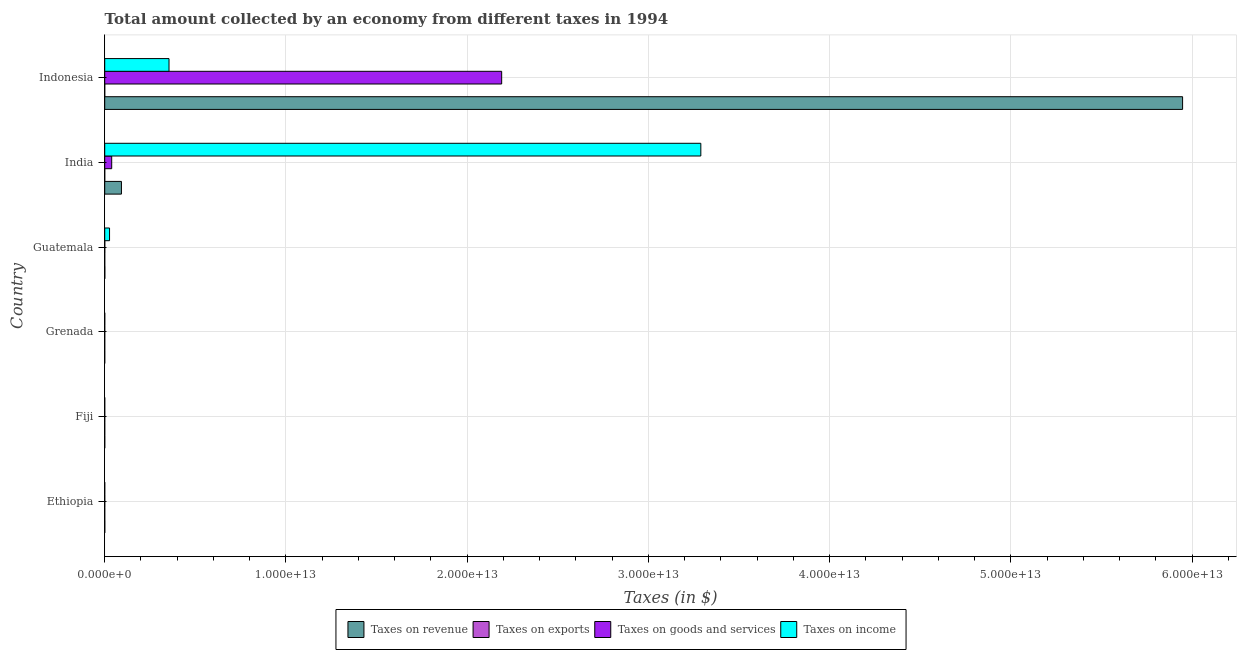How many different coloured bars are there?
Provide a short and direct response. 4. What is the amount collected as tax on goods in Grenada?
Offer a terse response. 8.10e+07. Across all countries, what is the maximum amount collected as tax on income?
Keep it short and to the point. 3.29e+13. Across all countries, what is the minimum amount collected as tax on income?
Your answer should be very brief. 3.48e+07. In which country was the amount collected as tax on exports maximum?
Your answer should be very brief. Fiji. What is the total amount collected as tax on exports in the graph?
Make the answer very short. 6.18e+08. What is the difference between the amount collected as tax on exports in Ethiopia and that in Guatemala?
Keep it short and to the point. -9.68e+07. What is the difference between the amount collected as tax on exports in Grenada and the amount collected as tax on goods in India?
Keep it short and to the point. -3.85e+11. What is the average amount collected as tax on income per country?
Offer a very short reply. 6.12e+12. What is the difference between the amount collected as tax on goods and amount collected as tax on income in Guatemala?
Give a very brief answer. -2.64e+11. In how many countries, is the amount collected as tax on income greater than 54000000000000 $?
Your response must be concise. 0. What is the ratio of the amount collected as tax on income in Guatemala to that in Indonesia?
Provide a short and direct response. 0.07. What is the difference between the highest and the second highest amount collected as tax on income?
Provide a short and direct response. 2.93e+13. What is the difference between the highest and the lowest amount collected as tax on revenue?
Your response must be concise. 5.95e+13. In how many countries, is the amount collected as tax on goods greater than the average amount collected as tax on goods taken over all countries?
Give a very brief answer. 1. Is the sum of the amount collected as tax on revenue in Ethiopia and Guatemala greater than the maximum amount collected as tax on income across all countries?
Your answer should be very brief. No. Is it the case that in every country, the sum of the amount collected as tax on exports and amount collected as tax on goods is greater than the sum of amount collected as tax on income and amount collected as tax on revenue?
Ensure brevity in your answer.  No. What does the 3rd bar from the top in Indonesia represents?
Your response must be concise. Taxes on exports. What does the 1st bar from the bottom in India represents?
Offer a very short reply. Taxes on revenue. How many bars are there?
Your answer should be compact. 24. What is the difference between two consecutive major ticks on the X-axis?
Keep it short and to the point. 1.00e+13. Are the values on the major ticks of X-axis written in scientific E-notation?
Provide a short and direct response. Yes. Does the graph contain any zero values?
Make the answer very short. No. Where does the legend appear in the graph?
Keep it short and to the point. Bottom center. How are the legend labels stacked?
Provide a succinct answer. Horizontal. What is the title of the graph?
Your response must be concise. Total amount collected by an economy from different taxes in 1994. Does "Secondary vocational" appear as one of the legend labels in the graph?
Offer a terse response. No. What is the label or title of the X-axis?
Give a very brief answer. Taxes (in $). What is the Taxes (in $) in Taxes on revenue in Ethiopia?
Provide a short and direct response. 3.08e+09. What is the Taxes (in $) of Taxes on exports in Ethiopia?
Keep it short and to the point. 4.00e+07. What is the Taxes (in $) of Taxes on goods and services in Ethiopia?
Offer a very short reply. 7.72e+08. What is the Taxes (in $) in Taxes on income in Ethiopia?
Offer a very short reply. 1.89e+08. What is the Taxes (in $) of Taxes on revenue in Fiji?
Give a very brief answer. 5.74e+08. What is the Taxes (in $) of Taxes on exports in Fiji?
Offer a terse response. 4.27e+08. What is the Taxes (in $) of Taxes on goods and services in Fiji?
Offer a terse response. 2.19e+08. What is the Taxes (in $) of Taxes on income in Fiji?
Make the answer very short. 3.48e+07. What is the Taxes (in $) of Taxes on revenue in Grenada?
Your answer should be compact. 1.58e+08. What is the Taxes (in $) of Taxes on exports in Grenada?
Make the answer very short. 1.36e+07. What is the Taxes (in $) in Taxes on goods and services in Grenada?
Ensure brevity in your answer.  8.10e+07. What is the Taxes (in $) in Taxes on income in Grenada?
Provide a short and direct response. 8.46e+08. What is the Taxes (in $) of Taxes on revenue in Guatemala?
Make the answer very short. 5.05e+09. What is the Taxes (in $) in Taxes on exports in Guatemala?
Your answer should be very brief. 1.37e+08. What is the Taxes (in $) of Taxes on goods and services in Guatemala?
Provide a succinct answer. 2.78e+09. What is the Taxes (in $) in Taxes on income in Guatemala?
Provide a succinct answer. 2.66e+11. What is the Taxes (in $) in Taxes on revenue in India?
Your response must be concise. 9.23e+11. What is the Taxes (in $) of Taxes on goods and services in India?
Your answer should be compact. 3.85e+11. What is the Taxes (in $) of Taxes on income in India?
Your response must be concise. 3.29e+13. What is the Taxes (in $) in Taxes on revenue in Indonesia?
Give a very brief answer. 5.95e+13. What is the Taxes (in $) of Taxes on exports in Indonesia?
Provide a succinct answer. 9.00e+05. What is the Taxes (in $) in Taxes on goods and services in Indonesia?
Provide a succinct answer. 2.19e+13. What is the Taxes (in $) in Taxes on income in Indonesia?
Your response must be concise. 3.55e+12. Across all countries, what is the maximum Taxes (in $) of Taxes on revenue?
Your response must be concise. 5.95e+13. Across all countries, what is the maximum Taxes (in $) of Taxes on exports?
Offer a very short reply. 4.27e+08. Across all countries, what is the maximum Taxes (in $) of Taxes on goods and services?
Your answer should be very brief. 2.19e+13. Across all countries, what is the maximum Taxes (in $) in Taxes on income?
Make the answer very short. 3.29e+13. Across all countries, what is the minimum Taxes (in $) of Taxes on revenue?
Provide a succinct answer. 1.58e+08. Across all countries, what is the minimum Taxes (in $) in Taxes on exports?
Provide a short and direct response. 10000. Across all countries, what is the minimum Taxes (in $) in Taxes on goods and services?
Make the answer very short. 8.10e+07. Across all countries, what is the minimum Taxes (in $) in Taxes on income?
Offer a very short reply. 3.48e+07. What is the total Taxes (in $) of Taxes on revenue in the graph?
Your answer should be very brief. 6.04e+13. What is the total Taxes (in $) in Taxes on exports in the graph?
Your answer should be compact. 6.18e+08. What is the total Taxes (in $) of Taxes on goods and services in the graph?
Your answer should be compact. 2.23e+13. What is the total Taxes (in $) in Taxes on income in the graph?
Offer a very short reply. 3.67e+13. What is the difference between the Taxes (in $) in Taxes on revenue in Ethiopia and that in Fiji?
Provide a short and direct response. 2.50e+09. What is the difference between the Taxes (in $) in Taxes on exports in Ethiopia and that in Fiji?
Give a very brief answer. -3.87e+08. What is the difference between the Taxes (in $) in Taxes on goods and services in Ethiopia and that in Fiji?
Provide a short and direct response. 5.53e+08. What is the difference between the Taxes (in $) of Taxes on income in Ethiopia and that in Fiji?
Provide a short and direct response. 1.54e+08. What is the difference between the Taxes (in $) of Taxes on revenue in Ethiopia and that in Grenada?
Offer a very short reply. 2.92e+09. What is the difference between the Taxes (in $) in Taxes on exports in Ethiopia and that in Grenada?
Keep it short and to the point. 2.64e+07. What is the difference between the Taxes (in $) in Taxes on goods and services in Ethiopia and that in Grenada?
Your answer should be very brief. 6.91e+08. What is the difference between the Taxes (in $) of Taxes on income in Ethiopia and that in Grenada?
Offer a very short reply. -6.57e+08. What is the difference between the Taxes (in $) in Taxes on revenue in Ethiopia and that in Guatemala?
Ensure brevity in your answer.  -1.98e+09. What is the difference between the Taxes (in $) of Taxes on exports in Ethiopia and that in Guatemala?
Your response must be concise. -9.68e+07. What is the difference between the Taxes (in $) in Taxes on goods and services in Ethiopia and that in Guatemala?
Give a very brief answer. -2.01e+09. What is the difference between the Taxes (in $) in Taxes on income in Ethiopia and that in Guatemala?
Make the answer very short. -2.66e+11. What is the difference between the Taxes (in $) of Taxes on revenue in Ethiopia and that in India?
Give a very brief answer. -9.20e+11. What is the difference between the Taxes (in $) in Taxes on exports in Ethiopia and that in India?
Keep it short and to the point. 4.00e+07. What is the difference between the Taxes (in $) of Taxes on goods and services in Ethiopia and that in India?
Give a very brief answer. -3.84e+11. What is the difference between the Taxes (in $) in Taxes on income in Ethiopia and that in India?
Offer a terse response. -3.29e+13. What is the difference between the Taxes (in $) in Taxes on revenue in Ethiopia and that in Indonesia?
Give a very brief answer. -5.95e+13. What is the difference between the Taxes (in $) in Taxes on exports in Ethiopia and that in Indonesia?
Ensure brevity in your answer.  3.91e+07. What is the difference between the Taxes (in $) of Taxes on goods and services in Ethiopia and that in Indonesia?
Provide a succinct answer. -2.19e+13. What is the difference between the Taxes (in $) in Taxes on income in Ethiopia and that in Indonesia?
Offer a very short reply. -3.55e+12. What is the difference between the Taxes (in $) of Taxes on revenue in Fiji and that in Grenada?
Keep it short and to the point. 4.17e+08. What is the difference between the Taxes (in $) of Taxes on exports in Fiji and that in Grenada?
Your answer should be compact. 4.13e+08. What is the difference between the Taxes (in $) of Taxes on goods and services in Fiji and that in Grenada?
Offer a very short reply. 1.38e+08. What is the difference between the Taxes (in $) of Taxes on income in Fiji and that in Grenada?
Your answer should be very brief. -8.11e+08. What is the difference between the Taxes (in $) in Taxes on revenue in Fiji and that in Guatemala?
Offer a terse response. -4.48e+09. What is the difference between the Taxes (in $) in Taxes on exports in Fiji and that in Guatemala?
Your answer should be very brief. 2.90e+08. What is the difference between the Taxes (in $) in Taxes on goods and services in Fiji and that in Guatemala?
Ensure brevity in your answer.  -2.56e+09. What is the difference between the Taxes (in $) in Taxes on income in Fiji and that in Guatemala?
Provide a short and direct response. -2.66e+11. What is the difference between the Taxes (in $) in Taxes on revenue in Fiji and that in India?
Make the answer very short. -9.22e+11. What is the difference between the Taxes (in $) of Taxes on exports in Fiji and that in India?
Provide a succinct answer. 4.27e+08. What is the difference between the Taxes (in $) in Taxes on goods and services in Fiji and that in India?
Give a very brief answer. -3.85e+11. What is the difference between the Taxes (in $) of Taxes on income in Fiji and that in India?
Provide a short and direct response. -3.29e+13. What is the difference between the Taxes (in $) of Taxes on revenue in Fiji and that in Indonesia?
Make the answer very short. -5.95e+13. What is the difference between the Taxes (in $) of Taxes on exports in Fiji and that in Indonesia?
Offer a terse response. 4.26e+08. What is the difference between the Taxes (in $) of Taxes on goods and services in Fiji and that in Indonesia?
Offer a terse response. -2.19e+13. What is the difference between the Taxes (in $) of Taxes on income in Fiji and that in Indonesia?
Your answer should be compact. -3.55e+12. What is the difference between the Taxes (in $) in Taxes on revenue in Grenada and that in Guatemala?
Make the answer very short. -4.89e+09. What is the difference between the Taxes (in $) of Taxes on exports in Grenada and that in Guatemala?
Provide a short and direct response. -1.23e+08. What is the difference between the Taxes (in $) of Taxes on goods and services in Grenada and that in Guatemala?
Provide a short and direct response. -2.70e+09. What is the difference between the Taxes (in $) in Taxes on income in Grenada and that in Guatemala?
Give a very brief answer. -2.66e+11. What is the difference between the Taxes (in $) in Taxes on revenue in Grenada and that in India?
Offer a very short reply. -9.23e+11. What is the difference between the Taxes (in $) of Taxes on exports in Grenada and that in India?
Make the answer very short. 1.36e+07. What is the difference between the Taxes (in $) of Taxes on goods and services in Grenada and that in India?
Ensure brevity in your answer.  -3.85e+11. What is the difference between the Taxes (in $) in Taxes on income in Grenada and that in India?
Your answer should be very brief. -3.29e+13. What is the difference between the Taxes (in $) in Taxes on revenue in Grenada and that in Indonesia?
Provide a short and direct response. -5.95e+13. What is the difference between the Taxes (in $) in Taxes on exports in Grenada and that in Indonesia?
Offer a terse response. 1.27e+07. What is the difference between the Taxes (in $) of Taxes on goods and services in Grenada and that in Indonesia?
Offer a terse response. -2.19e+13. What is the difference between the Taxes (in $) in Taxes on income in Grenada and that in Indonesia?
Keep it short and to the point. -3.55e+12. What is the difference between the Taxes (in $) in Taxes on revenue in Guatemala and that in India?
Provide a succinct answer. -9.18e+11. What is the difference between the Taxes (in $) in Taxes on exports in Guatemala and that in India?
Your answer should be very brief. 1.37e+08. What is the difference between the Taxes (in $) in Taxes on goods and services in Guatemala and that in India?
Offer a very short reply. -3.82e+11. What is the difference between the Taxes (in $) in Taxes on income in Guatemala and that in India?
Your answer should be compact. -3.26e+13. What is the difference between the Taxes (in $) in Taxes on revenue in Guatemala and that in Indonesia?
Offer a terse response. -5.95e+13. What is the difference between the Taxes (in $) of Taxes on exports in Guatemala and that in Indonesia?
Keep it short and to the point. 1.36e+08. What is the difference between the Taxes (in $) in Taxes on goods and services in Guatemala and that in Indonesia?
Your response must be concise. -2.19e+13. What is the difference between the Taxes (in $) in Taxes on income in Guatemala and that in Indonesia?
Keep it short and to the point. -3.28e+12. What is the difference between the Taxes (in $) in Taxes on revenue in India and that in Indonesia?
Give a very brief answer. -5.86e+13. What is the difference between the Taxes (in $) of Taxes on exports in India and that in Indonesia?
Provide a short and direct response. -8.90e+05. What is the difference between the Taxes (in $) in Taxes on goods and services in India and that in Indonesia?
Offer a terse response. -2.15e+13. What is the difference between the Taxes (in $) of Taxes on income in India and that in Indonesia?
Ensure brevity in your answer.  2.93e+13. What is the difference between the Taxes (in $) in Taxes on revenue in Ethiopia and the Taxes (in $) in Taxes on exports in Fiji?
Ensure brevity in your answer.  2.65e+09. What is the difference between the Taxes (in $) of Taxes on revenue in Ethiopia and the Taxes (in $) of Taxes on goods and services in Fiji?
Offer a terse response. 2.86e+09. What is the difference between the Taxes (in $) of Taxes on revenue in Ethiopia and the Taxes (in $) of Taxes on income in Fiji?
Ensure brevity in your answer.  3.04e+09. What is the difference between the Taxes (in $) of Taxes on exports in Ethiopia and the Taxes (in $) of Taxes on goods and services in Fiji?
Make the answer very short. -1.79e+08. What is the difference between the Taxes (in $) of Taxes on exports in Ethiopia and the Taxes (in $) of Taxes on income in Fiji?
Keep it short and to the point. 5.20e+06. What is the difference between the Taxes (in $) in Taxes on goods and services in Ethiopia and the Taxes (in $) in Taxes on income in Fiji?
Make the answer very short. 7.37e+08. What is the difference between the Taxes (in $) in Taxes on revenue in Ethiopia and the Taxes (in $) in Taxes on exports in Grenada?
Provide a short and direct response. 3.06e+09. What is the difference between the Taxes (in $) in Taxes on revenue in Ethiopia and the Taxes (in $) in Taxes on goods and services in Grenada?
Provide a short and direct response. 3.00e+09. What is the difference between the Taxes (in $) of Taxes on revenue in Ethiopia and the Taxes (in $) of Taxes on income in Grenada?
Provide a succinct answer. 2.23e+09. What is the difference between the Taxes (in $) of Taxes on exports in Ethiopia and the Taxes (in $) of Taxes on goods and services in Grenada?
Your answer should be very brief. -4.10e+07. What is the difference between the Taxes (in $) of Taxes on exports in Ethiopia and the Taxes (in $) of Taxes on income in Grenada?
Offer a terse response. -8.06e+08. What is the difference between the Taxes (in $) of Taxes on goods and services in Ethiopia and the Taxes (in $) of Taxes on income in Grenada?
Keep it short and to the point. -7.44e+07. What is the difference between the Taxes (in $) in Taxes on revenue in Ethiopia and the Taxes (in $) in Taxes on exports in Guatemala?
Provide a short and direct response. 2.94e+09. What is the difference between the Taxes (in $) of Taxes on revenue in Ethiopia and the Taxes (in $) of Taxes on goods and services in Guatemala?
Give a very brief answer. 2.97e+08. What is the difference between the Taxes (in $) in Taxes on revenue in Ethiopia and the Taxes (in $) in Taxes on income in Guatemala?
Keep it short and to the point. -2.63e+11. What is the difference between the Taxes (in $) in Taxes on exports in Ethiopia and the Taxes (in $) in Taxes on goods and services in Guatemala?
Offer a very short reply. -2.74e+09. What is the difference between the Taxes (in $) of Taxes on exports in Ethiopia and the Taxes (in $) of Taxes on income in Guatemala?
Give a very brief answer. -2.66e+11. What is the difference between the Taxes (in $) in Taxes on goods and services in Ethiopia and the Taxes (in $) in Taxes on income in Guatemala?
Give a very brief answer. -2.66e+11. What is the difference between the Taxes (in $) of Taxes on revenue in Ethiopia and the Taxes (in $) of Taxes on exports in India?
Your answer should be compact. 3.08e+09. What is the difference between the Taxes (in $) in Taxes on revenue in Ethiopia and the Taxes (in $) in Taxes on goods and services in India?
Your answer should be very brief. -3.82e+11. What is the difference between the Taxes (in $) of Taxes on revenue in Ethiopia and the Taxes (in $) of Taxes on income in India?
Ensure brevity in your answer.  -3.29e+13. What is the difference between the Taxes (in $) of Taxes on exports in Ethiopia and the Taxes (in $) of Taxes on goods and services in India?
Offer a very short reply. -3.85e+11. What is the difference between the Taxes (in $) in Taxes on exports in Ethiopia and the Taxes (in $) in Taxes on income in India?
Keep it short and to the point. -3.29e+13. What is the difference between the Taxes (in $) in Taxes on goods and services in Ethiopia and the Taxes (in $) in Taxes on income in India?
Your answer should be very brief. -3.29e+13. What is the difference between the Taxes (in $) of Taxes on revenue in Ethiopia and the Taxes (in $) of Taxes on exports in Indonesia?
Your response must be concise. 3.08e+09. What is the difference between the Taxes (in $) of Taxes on revenue in Ethiopia and the Taxes (in $) of Taxes on goods and services in Indonesia?
Your response must be concise. -2.19e+13. What is the difference between the Taxes (in $) in Taxes on revenue in Ethiopia and the Taxes (in $) in Taxes on income in Indonesia?
Your response must be concise. -3.54e+12. What is the difference between the Taxes (in $) of Taxes on exports in Ethiopia and the Taxes (in $) of Taxes on goods and services in Indonesia?
Offer a very short reply. -2.19e+13. What is the difference between the Taxes (in $) in Taxes on exports in Ethiopia and the Taxes (in $) in Taxes on income in Indonesia?
Give a very brief answer. -3.55e+12. What is the difference between the Taxes (in $) in Taxes on goods and services in Ethiopia and the Taxes (in $) in Taxes on income in Indonesia?
Make the answer very short. -3.55e+12. What is the difference between the Taxes (in $) of Taxes on revenue in Fiji and the Taxes (in $) of Taxes on exports in Grenada?
Provide a short and direct response. 5.61e+08. What is the difference between the Taxes (in $) of Taxes on revenue in Fiji and the Taxes (in $) of Taxes on goods and services in Grenada?
Provide a succinct answer. 4.93e+08. What is the difference between the Taxes (in $) of Taxes on revenue in Fiji and the Taxes (in $) of Taxes on income in Grenada?
Keep it short and to the point. -2.72e+08. What is the difference between the Taxes (in $) of Taxes on exports in Fiji and the Taxes (in $) of Taxes on goods and services in Grenada?
Ensure brevity in your answer.  3.46e+08. What is the difference between the Taxes (in $) of Taxes on exports in Fiji and the Taxes (in $) of Taxes on income in Grenada?
Give a very brief answer. -4.19e+08. What is the difference between the Taxes (in $) in Taxes on goods and services in Fiji and the Taxes (in $) in Taxes on income in Grenada?
Ensure brevity in your answer.  -6.27e+08. What is the difference between the Taxes (in $) in Taxes on revenue in Fiji and the Taxes (in $) in Taxes on exports in Guatemala?
Offer a very short reply. 4.38e+08. What is the difference between the Taxes (in $) of Taxes on revenue in Fiji and the Taxes (in $) of Taxes on goods and services in Guatemala?
Offer a terse response. -2.20e+09. What is the difference between the Taxes (in $) of Taxes on revenue in Fiji and the Taxes (in $) of Taxes on income in Guatemala?
Make the answer very short. -2.66e+11. What is the difference between the Taxes (in $) in Taxes on exports in Fiji and the Taxes (in $) in Taxes on goods and services in Guatemala?
Offer a very short reply. -2.35e+09. What is the difference between the Taxes (in $) in Taxes on exports in Fiji and the Taxes (in $) in Taxes on income in Guatemala?
Provide a short and direct response. -2.66e+11. What is the difference between the Taxes (in $) of Taxes on goods and services in Fiji and the Taxes (in $) of Taxes on income in Guatemala?
Provide a succinct answer. -2.66e+11. What is the difference between the Taxes (in $) of Taxes on revenue in Fiji and the Taxes (in $) of Taxes on exports in India?
Offer a very short reply. 5.74e+08. What is the difference between the Taxes (in $) of Taxes on revenue in Fiji and the Taxes (in $) of Taxes on goods and services in India?
Provide a short and direct response. -3.85e+11. What is the difference between the Taxes (in $) of Taxes on revenue in Fiji and the Taxes (in $) of Taxes on income in India?
Provide a succinct answer. -3.29e+13. What is the difference between the Taxes (in $) of Taxes on exports in Fiji and the Taxes (in $) of Taxes on goods and services in India?
Provide a short and direct response. -3.85e+11. What is the difference between the Taxes (in $) in Taxes on exports in Fiji and the Taxes (in $) in Taxes on income in India?
Provide a short and direct response. -3.29e+13. What is the difference between the Taxes (in $) in Taxes on goods and services in Fiji and the Taxes (in $) in Taxes on income in India?
Your response must be concise. -3.29e+13. What is the difference between the Taxes (in $) in Taxes on revenue in Fiji and the Taxes (in $) in Taxes on exports in Indonesia?
Provide a succinct answer. 5.74e+08. What is the difference between the Taxes (in $) in Taxes on revenue in Fiji and the Taxes (in $) in Taxes on goods and services in Indonesia?
Make the answer very short. -2.19e+13. What is the difference between the Taxes (in $) in Taxes on revenue in Fiji and the Taxes (in $) in Taxes on income in Indonesia?
Your answer should be compact. -3.55e+12. What is the difference between the Taxes (in $) in Taxes on exports in Fiji and the Taxes (in $) in Taxes on goods and services in Indonesia?
Give a very brief answer. -2.19e+13. What is the difference between the Taxes (in $) of Taxes on exports in Fiji and the Taxes (in $) of Taxes on income in Indonesia?
Keep it short and to the point. -3.55e+12. What is the difference between the Taxes (in $) in Taxes on goods and services in Fiji and the Taxes (in $) in Taxes on income in Indonesia?
Give a very brief answer. -3.55e+12. What is the difference between the Taxes (in $) of Taxes on revenue in Grenada and the Taxes (in $) of Taxes on exports in Guatemala?
Ensure brevity in your answer.  2.11e+07. What is the difference between the Taxes (in $) of Taxes on revenue in Grenada and the Taxes (in $) of Taxes on goods and services in Guatemala?
Provide a succinct answer. -2.62e+09. What is the difference between the Taxes (in $) in Taxes on revenue in Grenada and the Taxes (in $) in Taxes on income in Guatemala?
Keep it short and to the point. -2.66e+11. What is the difference between the Taxes (in $) of Taxes on exports in Grenada and the Taxes (in $) of Taxes on goods and services in Guatemala?
Provide a succinct answer. -2.77e+09. What is the difference between the Taxes (in $) of Taxes on exports in Grenada and the Taxes (in $) of Taxes on income in Guatemala?
Give a very brief answer. -2.66e+11. What is the difference between the Taxes (in $) of Taxes on goods and services in Grenada and the Taxes (in $) of Taxes on income in Guatemala?
Offer a very short reply. -2.66e+11. What is the difference between the Taxes (in $) in Taxes on revenue in Grenada and the Taxes (in $) in Taxes on exports in India?
Provide a short and direct response. 1.58e+08. What is the difference between the Taxes (in $) of Taxes on revenue in Grenada and the Taxes (in $) of Taxes on goods and services in India?
Your answer should be very brief. -3.85e+11. What is the difference between the Taxes (in $) of Taxes on revenue in Grenada and the Taxes (in $) of Taxes on income in India?
Keep it short and to the point. -3.29e+13. What is the difference between the Taxes (in $) in Taxes on exports in Grenada and the Taxes (in $) in Taxes on goods and services in India?
Provide a succinct answer. -3.85e+11. What is the difference between the Taxes (in $) in Taxes on exports in Grenada and the Taxes (in $) in Taxes on income in India?
Your answer should be compact. -3.29e+13. What is the difference between the Taxes (in $) of Taxes on goods and services in Grenada and the Taxes (in $) of Taxes on income in India?
Keep it short and to the point. -3.29e+13. What is the difference between the Taxes (in $) in Taxes on revenue in Grenada and the Taxes (in $) in Taxes on exports in Indonesia?
Ensure brevity in your answer.  1.57e+08. What is the difference between the Taxes (in $) of Taxes on revenue in Grenada and the Taxes (in $) of Taxes on goods and services in Indonesia?
Make the answer very short. -2.19e+13. What is the difference between the Taxes (in $) of Taxes on revenue in Grenada and the Taxes (in $) of Taxes on income in Indonesia?
Provide a succinct answer. -3.55e+12. What is the difference between the Taxes (in $) of Taxes on exports in Grenada and the Taxes (in $) of Taxes on goods and services in Indonesia?
Provide a succinct answer. -2.19e+13. What is the difference between the Taxes (in $) of Taxes on exports in Grenada and the Taxes (in $) of Taxes on income in Indonesia?
Offer a terse response. -3.55e+12. What is the difference between the Taxes (in $) in Taxes on goods and services in Grenada and the Taxes (in $) in Taxes on income in Indonesia?
Keep it short and to the point. -3.55e+12. What is the difference between the Taxes (in $) in Taxes on revenue in Guatemala and the Taxes (in $) in Taxes on exports in India?
Give a very brief answer. 5.05e+09. What is the difference between the Taxes (in $) of Taxes on revenue in Guatemala and the Taxes (in $) of Taxes on goods and services in India?
Your answer should be very brief. -3.80e+11. What is the difference between the Taxes (in $) in Taxes on revenue in Guatemala and the Taxes (in $) in Taxes on income in India?
Provide a short and direct response. -3.29e+13. What is the difference between the Taxes (in $) in Taxes on exports in Guatemala and the Taxes (in $) in Taxes on goods and services in India?
Make the answer very short. -3.85e+11. What is the difference between the Taxes (in $) of Taxes on exports in Guatemala and the Taxes (in $) of Taxes on income in India?
Offer a terse response. -3.29e+13. What is the difference between the Taxes (in $) of Taxes on goods and services in Guatemala and the Taxes (in $) of Taxes on income in India?
Give a very brief answer. -3.29e+13. What is the difference between the Taxes (in $) in Taxes on revenue in Guatemala and the Taxes (in $) in Taxes on exports in Indonesia?
Keep it short and to the point. 5.05e+09. What is the difference between the Taxes (in $) of Taxes on revenue in Guatemala and the Taxes (in $) of Taxes on goods and services in Indonesia?
Give a very brief answer. -2.19e+13. What is the difference between the Taxes (in $) in Taxes on revenue in Guatemala and the Taxes (in $) in Taxes on income in Indonesia?
Your answer should be very brief. -3.54e+12. What is the difference between the Taxes (in $) in Taxes on exports in Guatemala and the Taxes (in $) in Taxes on goods and services in Indonesia?
Make the answer very short. -2.19e+13. What is the difference between the Taxes (in $) in Taxes on exports in Guatemala and the Taxes (in $) in Taxes on income in Indonesia?
Your answer should be compact. -3.55e+12. What is the difference between the Taxes (in $) in Taxes on goods and services in Guatemala and the Taxes (in $) in Taxes on income in Indonesia?
Your response must be concise. -3.55e+12. What is the difference between the Taxes (in $) in Taxes on revenue in India and the Taxes (in $) in Taxes on exports in Indonesia?
Your response must be concise. 9.23e+11. What is the difference between the Taxes (in $) in Taxes on revenue in India and the Taxes (in $) in Taxes on goods and services in Indonesia?
Make the answer very short. -2.10e+13. What is the difference between the Taxes (in $) of Taxes on revenue in India and the Taxes (in $) of Taxes on income in Indonesia?
Make the answer very short. -2.63e+12. What is the difference between the Taxes (in $) in Taxes on exports in India and the Taxes (in $) in Taxes on goods and services in Indonesia?
Your answer should be very brief. -2.19e+13. What is the difference between the Taxes (in $) in Taxes on exports in India and the Taxes (in $) in Taxes on income in Indonesia?
Ensure brevity in your answer.  -3.55e+12. What is the difference between the Taxes (in $) of Taxes on goods and services in India and the Taxes (in $) of Taxes on income in Indonesia?
Your answer should be very brief. -3.16e+12. What is the average Taxes (in $) of Taxes on revenue per country?
Keep it short and to the point. 1.01e+13. What is the average Taxes (in $) in Taxes on exports per country?
Offer a terse response. 1.03e+08. What is the average Taxes (in $) in Taxes on goods and services per country?
Provide a succinct answer. 3.72e+12. What is the average Taxes (in $) of Taxes on income per country?
Provide a short and direct response. 6.12e+12. What is the difference between the Taxes (in $) of Taxes on revenue and Taxes (in $) of Taxes on exports in Ethiopia?
Give a very brief answer. 3.04e+09. What is the difference between the Taxes (in $) of Taxes on revenue and Taxes (in $) of Taxes on goods and services in Ethiopia?
Make the answer very short. 2.30e+09. What is the difference between the Taxes (in $) in Taxes on revenue and Taxes (in $) in Taxes on income in Ethiopia?
Offer a very short reply. 2.89e+09. What is the difference between the Taxes (in $) of Taxes on exports and Taxes (in $) of Taxes on goods and services in Ethiopia?
Provide a succinct answer. -7.32e+08. What is the difference between the Taxes (in $) of Taxes on exports and Taxes (in $) of Taxes on income in Ethiopia?
Offer a terse response. -1.49e+08. What is the difference between the Taxes (in $) of Taxes on goods and services and Taxes (in $) of Taxes on income in Ethiopia?
Offer a terse response. 5.83e+08. What is the difference between the Taxes (in $) in Taxes on revenue and Taxes (in $) in Taxes on exports in Fiji?
Give a very brief answer. 1.47e+08. What is the difference between the Taxes (in $) in Taxes on revenue and Taxes (in $) in Taxes on goods and services in Fiji?
Offer a very short reply. 3.55e+08. What is the difference between the Taxes (in $) of Taxes on revenue and Taxes (in $) of Taxes on income in Fiji?
Provide a succinct answer. 5.40e+08. What is the difference between the Taxes (in $) of Taxes on exports and Taxes (in $) of Taxes on goods and services in Fiji?
Provide a short and direct response. 2.08e+08. What is the difference between the Taxes (in $) in Taxes on exports and Taxes (in $) in Taxes on income in Fiji?
Your answer should be very brief. 3.92e+08. What is the difference between the Taxes (in $) of Taxes on goods and services and Taxes (in $) of Taxes on income in Fiji?
Your response must be concise. 1.84e+08. What is the difference between the Taxes (in $) in Taxes on revenue and Taxes (in $) in Taxes on exports in Grenada?
Your response must be concise. 1.44e+08. What is the difference between the Taxes (in $) in Taxes on revenue and Taxes (in $) in Taxes on goods and services in Grenada?
Provide a succinct answer. 7.69e+07. What is the difference between the Taxes (in $) in Taxes on revenue and Taxes (in $) in Taxes on income in Grenada?
Keep it short and to the point. -6.88e+08. What is the difference between the Taxes (in $) of Taxes on exports and Taxes (in $) of Taxes on goods and services in Grenada?
Your response must be concise. -6.74e+07. What is the difference between the Taxes (in $) of Taxes on exports and Taxes (in $) of Taxes on income in Grenada?
Provide a short and direct response. -8.33e+08. What is the difference between the Taxes (in $) in Taxes on goods and services and Taxes (in $) in Taxes on income in Grenada?
Offer a very short reply. -7.65e+08. What is the difference between the Taxes (in $) in Taxes on revenue and Taxes (in $) in Taxes on exports in Guatemala?
Your answer should be compact. 4.91e+09. What is the difference between the Taxes (in $) of Taxes on revenue and Taxes (in $) of Taxes on goods and services in Guatemala?
Keep it short and to the point. 2.27e+09. What is the difference between the Taxes (in $) in Taxes on revenue and Taxes (in $) in Taxes on income in Guatemala?
Provide a short and direct response. -2.61e+11. What is the difference between the Taxes (in $) of Taxes on exports and Taxes (in $) of Taxes on goods and services in Guatemala?
Offer a terse response. -2.64e+09. What is the difference between the Taxes (in $) in Taxes on exports and Taxes (in $) in Taxes on income in Guatemala?
Provide a succinct answer. -2.66e+11. What is the difference between the Taxes (in $) in Taxes on goods and services and Taxes (in $) in Taxes on income in Guatemala?
Provide a succinct answer. -2.64e+11. What is the difference between the Taxes (in $) in Taxes on revenue and Taxes (in $) in Taxes on exports in India?
Keep it short and to the point. 9.23e+11. What is the difference between the Taxes (in $) of Taxes on revenue and Taxes (in $) of Taxes on goods and services in India?
Keep it short and to the point. 5.38e+11. What is the difference between the Taxes (in $) of Taxes on revenue and Taxes (in $) of Taxes on income in India?
Ensure brevity in your answer.  -3.20e+13. What is the difference between the Taxes (in $) of Taxes on exports and Taxes (in $) of Taxes on goods and services in India?
Your answer should be compact. -3.85e+11. What is the difference between the Taxes (in $) in Taxes on exports and Taxes (in $) in Taxes on income in India?
Your response must be concise. -3.29e+13. What is the difference between the Taxes (in $) of Taxes on goods and services and Taxes (in $) of Taxes on income in India?
Offer a terse response. -3.25e+13. What is the difference between the Taxes (in $) of Taxes on revenue and Taxes (in $) of Taxes on exports in Indonesia?
Provide a succinct answer. 5.95e+13. What is the difference between the Taxes (in $) in Taxes on revenue and Taxes (in $) in Taxes on goods and services in Indonesia?
Your answer should be very brief. 3.76e+13. What is the difference between the Taxes (in $) in Taxes on revenue and Taxes (in $) in Taxes on income in Indonesia?
Keep it short and to the point. 5.59e+13. What is the difference between the Taxes (in $) of Taxes on exports and Taxes (in $) of Taxes on goods and services in Indonesia?
Provide a succinct answer. -2.19e+13. What is the difference between the Taxes (in $) of Taxes on exports and Taxes (in $) of Taxes on income in Indonesia?
Give a very brief answer. -3.55e+12. What is the difference between the Taxes (in $) of Taxes on goods and services and Taxes (in $) of Taxes on income in Indonesia?
Your answer should be compact. 1.84e+13. What is the ratio of the Taxes (in $) of Taxes on revenue in Ethiopia to that in Fiji?
Offer a very short reply. 5.36. What is the ratio of the Taxes (in $) in Taxes on exports in Ethiopia to that in Fiji?
Provide a short and direct response. 0.09. What is the ratio of the Taxes (in $) of Taxes on goods and services in Ethiopia to that in Fiji?
Your answer should be very brief. 3.52. What is the ratio of the Taxes (in $) of Taxes on income in Ethiopia to that in Fiji?
Ensure brevity in your answer.  5.43. What is the ratio of the Taxes (in $) in Taxes on revenue in Ethiopia to that in Grenada?
Ensure brevity in your answer.  19.49. What is the ratio of the Taxes (in $) of Taxes on exports in Ethiopia to that in Grenada?
Make the answer very short. 2.94. What is the ratio of the Taxes (in $) in Taxes on goods and services in Ethiopia to that in Grenada?
Make the answer very short. 9.53. What is the ratio of the Taxes (in $) in Taxes on income in Ethiopia to that in Grenada?
Give a very brief answer. 0.22. What is the ratio of the Taxes (in $) of Taxes on revenue in Ethiopia to that in Guatemala?
Your answer should be compact. 0.61. What is the ratio of the Taxes (in $) of Taxes on exports in Ethiopia to that in Guatemala?
Make the answer very short. 0.29. What is the ratio of the Taxes (in $) in Taxes on goods and services in Ethiopia to that in Guatemala?
Make the answer very short. 0.28. What is the ratio of the Taxes (in $) of Taxes on income in Ethiopia to that in Guatemala?
Your response must be concise. 0. What is the ratio of the Taxes (in $) in Taxes on revenue in Ethiopia to that in India?
Ensure brevity in your answer.  0. What is the ratio of the Taxes (in $) in Taxes on exports in Ethiopia to that in India?
Offer a terse response. 4000. What is the ratio of the Taxes (in $) of Taxes on goods and services in Ethiopia to that in India?
Your response must be concise. 0. What is the ratio of the Taxes (in $) of Taxes on income in Ethiopia to that in India?
Provide a short and direct response. 0. What is the ratio of the Taxes (in $) of Taxes on exports in Ethiopia to that in Indonesia?
Your answer should be compact. 44.44. What is the ratio of the Taxes (in $) of Taxes on goods and services in Ethiopia to that in Indonesia?
Give a very brief answer. 0. What is the ratio of the Taxes (in $) of Taxes on revenue in Fiji to that in Grenada?
Provide a short and direct response. 3.64. What is the ratio of the Taxes (in $) in Taxes on exports in Fiji to that in Grenada?
Provide a succinct answer. 31.4. What is the ratio of the Taxes (in $) in Taxes on goods and services in Fiji to that in Grenada?
Your response must be concise. 2.71. What is the ratio of the Taxes (in $) of Taxes on income in Fiji to that in Grenada?
Your response must be concise. 0.04. What is the ratio of the Taxes (in $) in Taxes on revenue in Fiji to that in Guatemala?
Keep it short and to the point. 0.11. What is the ratio of the Taxes (in $) of Taxes on exports in Fiji to that in Guatemala?
Provide a succinct answer. 3.12. What is the ratio of the Taxes (in $) of Taxes on goods and services in Fiji to that in Guatemala?
Make the answer very short. 0.08. What is the ratio of the Taxes (in $) in Taxes on revenue in Fiji to that in India?
Your answer should be compact. 0. What is the ratio of the Taxes (in $) of Taxes on exports in Fiji to that in India?
Make the answer very short. 4.27e+04. What is the ratio of the Taxes (in $) in Taxes on goods and services in Fiji to that in India?
Give a very brief answer. 0. What is the ratio of the Taxes (in $) in Taxes on income in Fiji to that in India?
Give a very brief answer. 0. What is the ratio of the Taxes (in $) of Taxes on exports in Fiji to that in Indonesia?
Make the answer very short. 474.44. What is the ratio of the Taxes (in $) of Taxes on revenue in Grenada to that in Guatemala?
Offer a very short reply. 0.03. What is the ratio of the Taxes (in $) of Taxes on exports in Grenada to that in Guatemala?
Your answer should be compact. 0.1. What is the ratio of the Taxes (in $) in Taxes on goods and services in Grenada to that in Guatemala?
Keep it short and to the point. 0.03. What is the ratio of the Taxes (in $) of Taxes on income in Grenada to that in Guatemala?
Ensure brevity in your answer.  0. What is the ratio of the Taxes (in $) in Taxes on exports in Grenada to that in India?
Make the answer very short. 1360. What is the ratio of the Taxes (in $) of Taxes on income in Grenada to that in India?
Make the answer very short. 0. What is the ratio of the Taxes (in $) of Taxes on exports in Grenada to that in Indonesia?
Offer a terse response. 15.11. What is the ratio of the Taxes (in $) in Taxes on goods and services in Grenada to that in Indonesia?
Keep it short and to the point. 0. What is the ratio of the Taxes (in $) in Taxes on income in Grenada to that in Indonesia?
Give a very brief answer. 0. What is the ratio of the Taxes (in $) of Taxes on revenue in Guatemala to that in India?
Your answer should be very brief. 0.01. What is the ratio of the Taxes (in $) of Taxes on exports in Guatemala to that in India?
Your response must be concise. 1.37e+04. What is the ratio of the Taxes (in $) in Taxes on goods and services in Guatemala to that in India?
Provide a short and direct response. 0.01. What is the ratio of the Taxes (in $) in Taxes on income in Guatemala to that in India?
Your answer should be very brief. 0.01. What is the ratio of the Taxes (in $) in Taxes on revenue in Guatemala to that in Indonesia?
Provide a succinct answer. 0. What is the ratio of the Taxes (in $) in Taxes on exports in Guatemala to that in Indonesia?
Your response must be concise. 152.02. What is the ratio of the Taxes (in $) in Taxes on goods and services in Guatemala to that in Indonesia?
Ensure brevity in your answer.  0. What is the ratio of the Taxes (in $) in Taxes on income in Guatemala to that in Indonesia?
Your answer should be very brief. 0.08. What is the ratio of the Taxes (in $) of Taxes on revenue in India to that in Indonesia?
Offer a terse response. 0.02. What is the ratio of the Taxes (in $) of Taxes on exports in India to that in Indonesia?
Keep it short and to the point. 0.01. What is the ratio of the Taxes (in $) in Taxes on goods and services in India to that in Indonesia?
Give a very brief answer. 0.02. What is the ratio of the Taxes (in $) in Taxes on income in India to that in Indonesia?
Your response must be concise. 9.27. What is the difference between the highest and the second highest Taxes (in $) in Taxes on revenue?
Your response must be concise. 5.86e+13. What is the difference between the highest and the second highest Taxes (in $) in Taxes on exports?
Make the answer very short. 2.90e+08. What is the difference between the highest and the second highest Taxes (in $) in Taxes on goods and services?
Your response must be concise. 2.15e+13. What is the difference between the highest and the second highest Taxes (in $) in Taxes on income?
Provide a succinct answer. 2.93e+13. What is the difference between the highest and the lowest Taxes (in $) of Taxes on revenue?
Offer a terse response. 5.95e+13. What is the difference between the highest and the lowest Taxes (in $) in Taxes on exports?
Offer a terse response. 4.27e+08. What is the difference between the highest and the lowest Taxes (in $) in Taxes on goods and services?
Give a very brief answer. 2.19e+13. What is the difference between the highest and the lowest Taxes (in $) of Taxes on income?
Keep it short and to the point. 3.29e+13. 